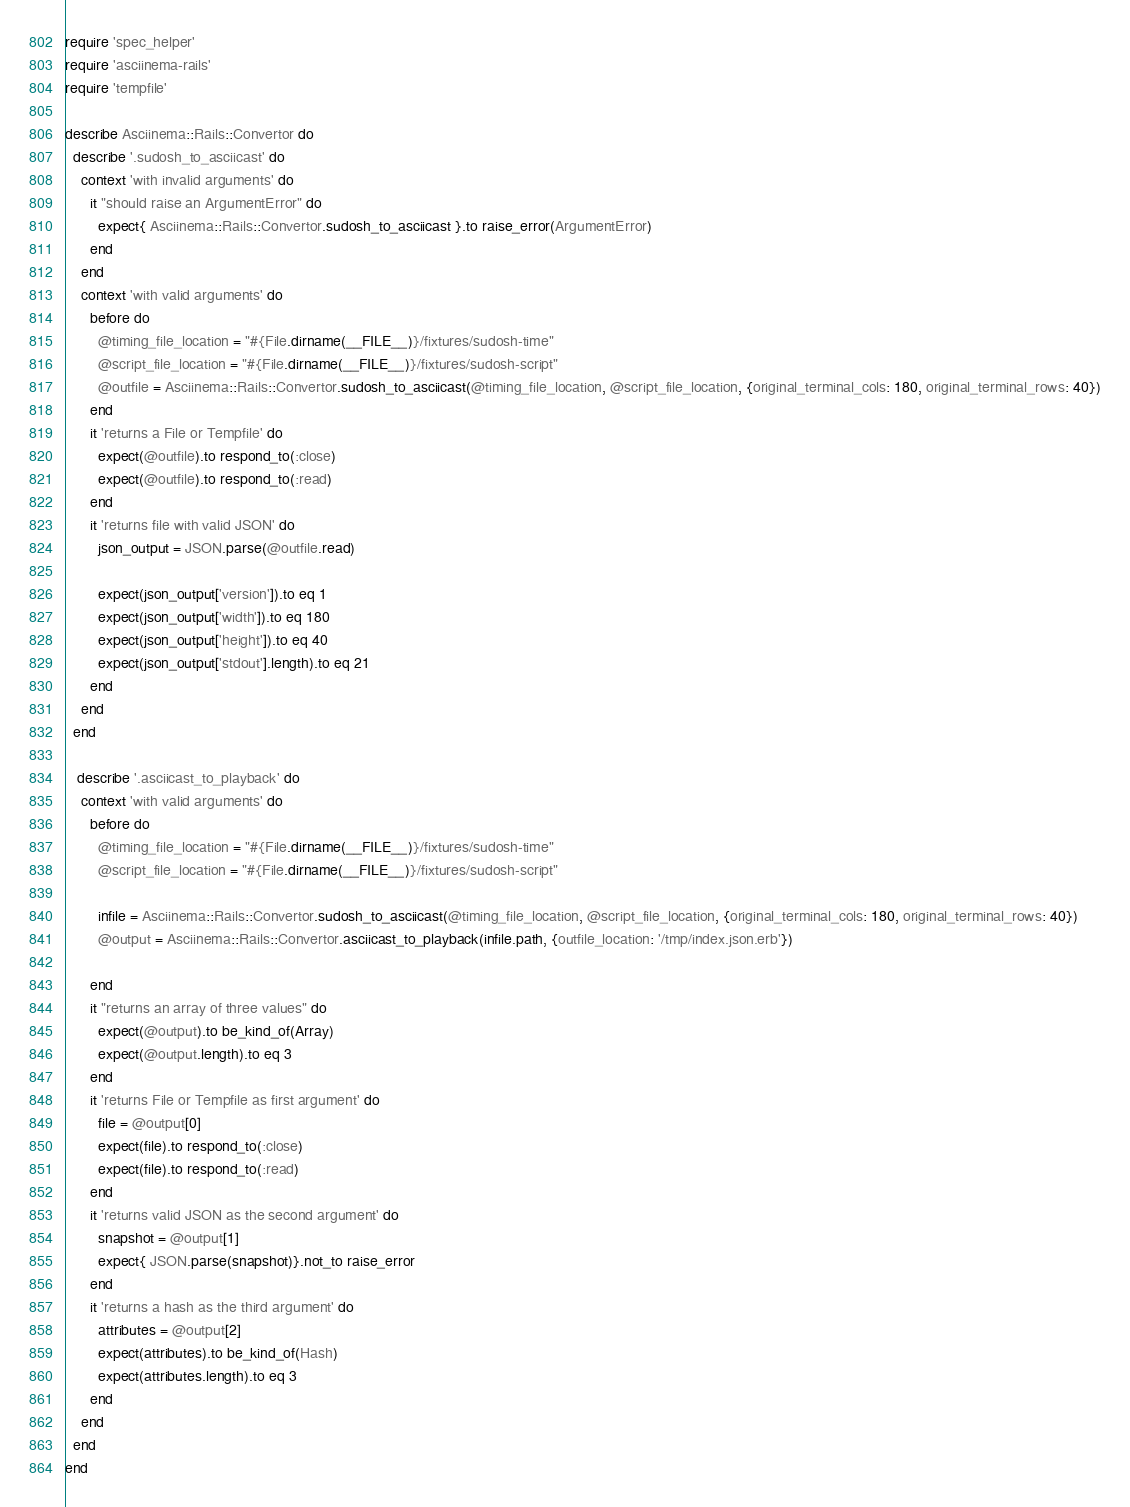Convert code to text. <code><loc_0><loc_0><loc_500><loc_500><_Ruby_>require 'spec_helper'
require 'asciinema-rails'
require 'tempfile'

describe Asciinema::Rails::Convertor do
  describe '.sudosh_to_asciicast' do
    context 'with invalid arguments' do
      it "should raise an ArgumentError" do
        expect{ Asciinema::Rails::Convertor.sudosh_to_asciicast }.to raise_error(ArgumentError)
      end
    end
    context 'with valid arguments' do
      before do
        @timing_file_location = "#{File.dirname(__FILE__)}/fixtures/sudosh-time"
        @script_file_location = "#{File.dirname(__FILE__)}/fixtures/sudosh-script"
        @outfile = Asciinema::Rails::Convertor.sudosh_to_asciicast(@timing_file_location, @script_file_location, {original_terminal_cols: 180, original_terminal_rows: 40})
      end
      it 'returns a File or Tempfile' do
        expect(@outfile).to respond_to(:close)
        expect(@outfile).to respond_to(:read)
      end
      it 'returns file with valid JSON' do
        json_output = JSON.parse(@outfile.read)
        
        expect(json_output['version']).to eq 1
        expect(json_output['width']).to eq 180
        expect(json_output['height']).to eq 40
        expect(json_output['stdout'].length).to eq 21
      end
    end
  end

   describe '.asciicast_to_playback' do
    context 'with valid arguments' do
      before do
        @timing_file_location = "#{File.dirname(__FILE__)}/fixtures/sudosh-time"
        @script_file_location = "#{File.dirname(__FILE__)}/fixtures/sudosh-script"
        
        infile = Asciinema::Rails::Convertor.sudosh_to_asciicast(@timing_file_location, @script_file_location, {original_terminal_cols: 180, original_terminal_rows: 40})
        @output = Asciinema::Rails::Convertor.asciicast_to_playback(infile.path, {outfile_location: '/tmp/index.json.erb'})
        
      end
      it "returns an array of three values" do
        expect(@output).to be_kind_of(Array) 
        expect(@output.length).to eq 3
      end
      it 'returns File or Tempfile as first argument' do
        file = @output[0]
        expect(file).to respond_to(:close)
        expect(file).to respond_to(:read)
      end
      it 'returns valid JSON as the second argument' do
        snapshot = @output[1]
        expect{ JSON.parse(snapshot)}.not_to raise_error    
      end
      it 'returns a hash as the third argument' do
        attributes = @output[2]
        expect(attributes).to be_kind_of(Hash) 
        expect(attributes.length).to eq 3
      end
    end
  end
end
</code> 